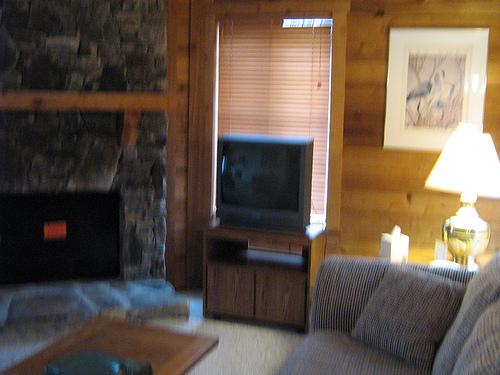Is the chair blue?
Answer briefly. No. What sort of blind is covering the window?
Concise answer only. Wood. Is it a tube TV or flat screen?
Quick response, please. Tube. Is the fireplace wood burning?
Concise answer only. No. Is the photo clear?
Give a very brief answer. No. Which table has a lamp?
Be succinct. End table. Are all the shutters closed?
Concise answer only. Yes. Is this during the day time?
Keep it brief. Yes. What are the floors made out of?
Write a very short answer. Carpet. What color is the floor?
Keep it brief. Gray. What is the television sitting above?
Write a very short answer. Tv stand. 